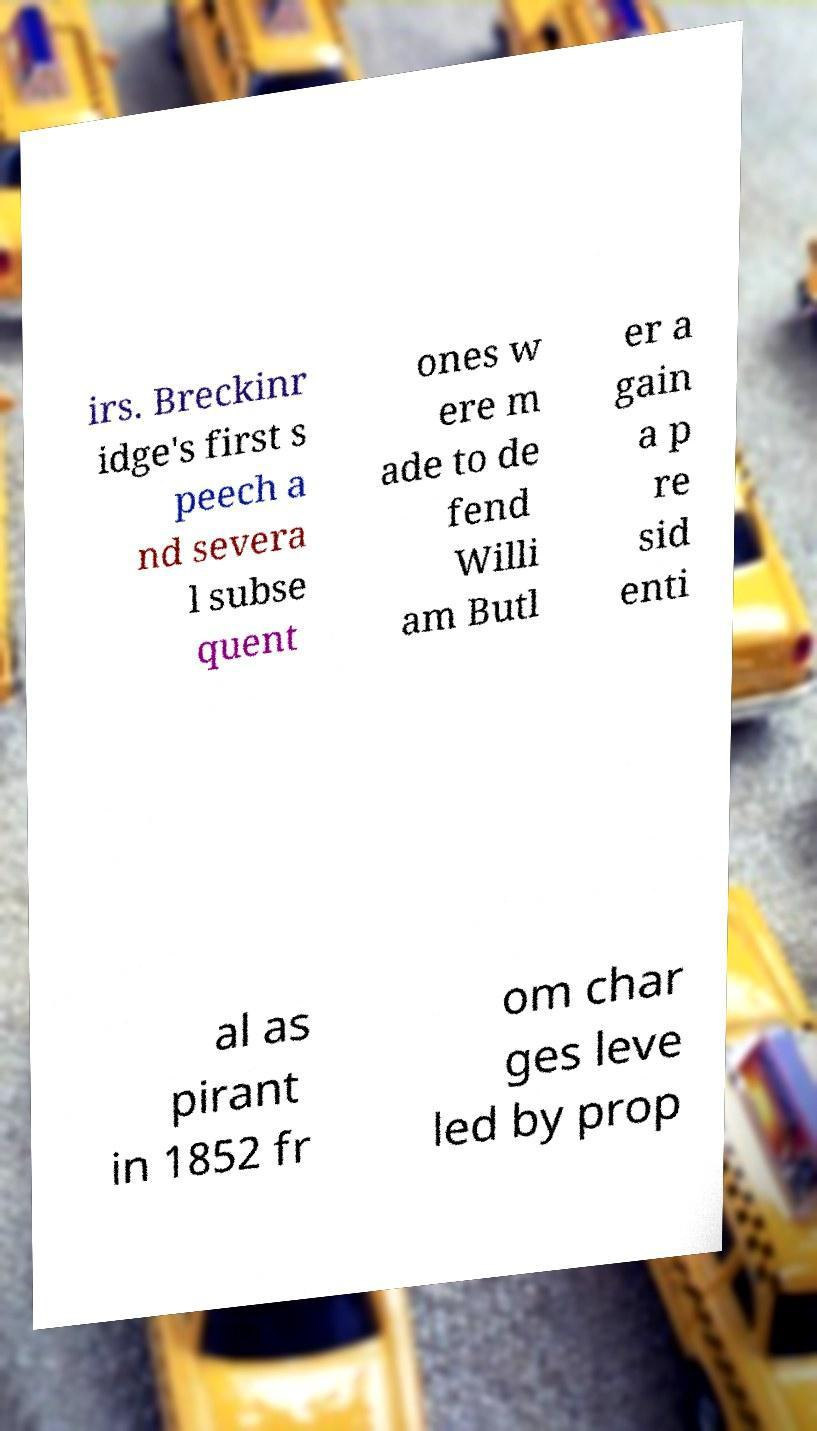For documentation purposes, I need the text within this image transcribed. Could you provide that? irs. Breckinr idge's first s peech a nd severa l subse quent ones w ere m ade to de fend Willi am Butl er a gain a p re sid enti al as pirant in 1852 fr om char ges leve led by prop 